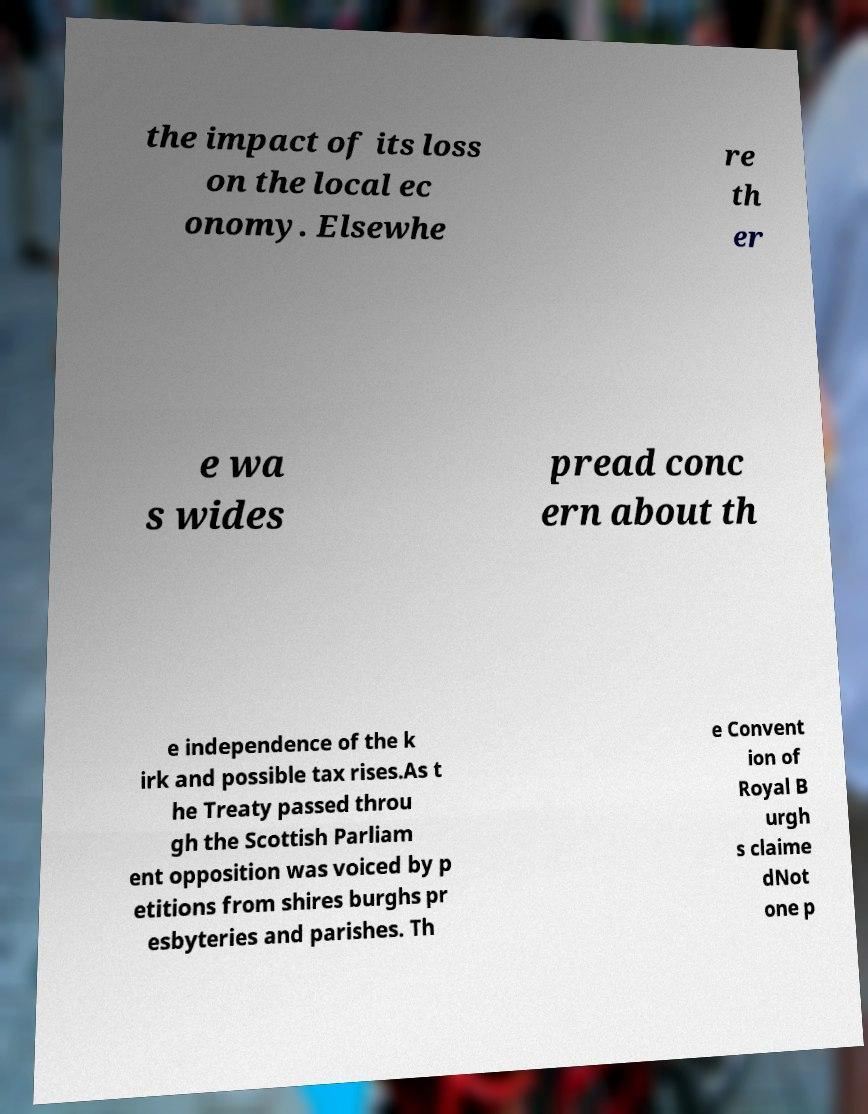I need the written content from this picture converted into text. Can you do that? the impact of its loss on the local ec onomy. Elsewhe re th er e wa s wides pread conc ern about th e independence of the k irk and possible tax rises.As t he Treaty passed throu gh the Scottish Parliam ent opposition was voiced by p etitions from shires burghs pr esbyteries and parishes. Th e Convent ion of Royal B urgh s claime dNot one p 